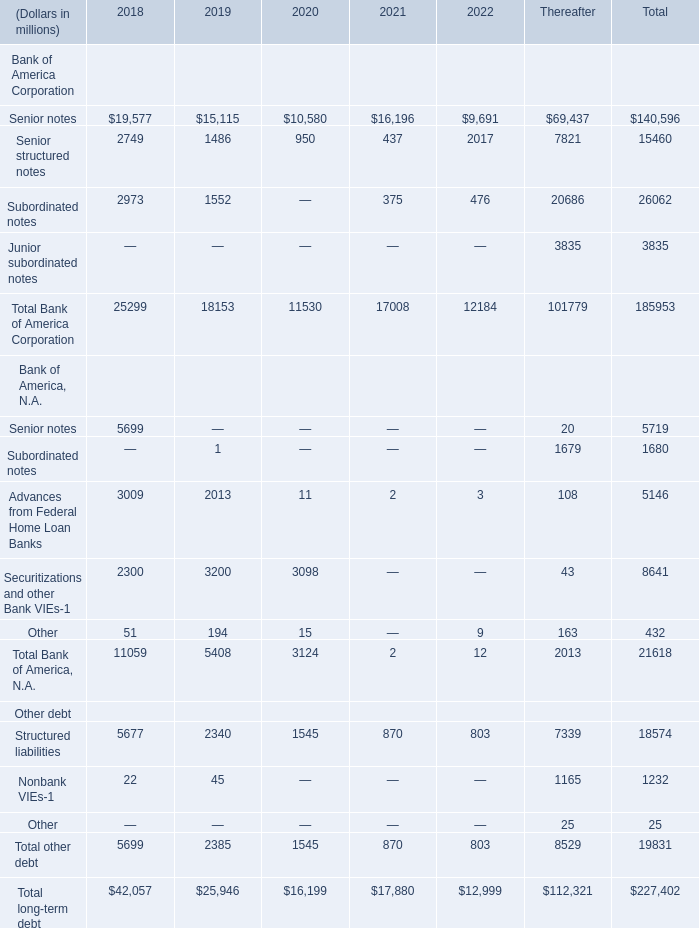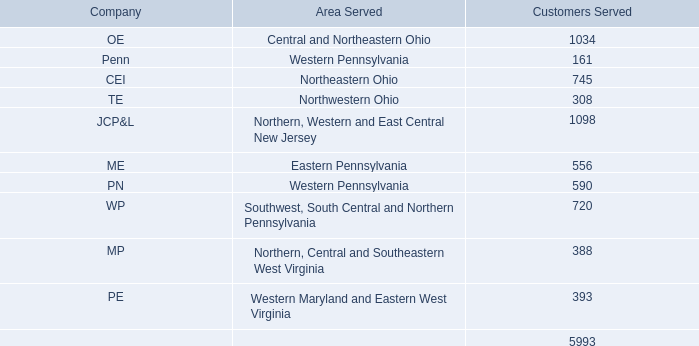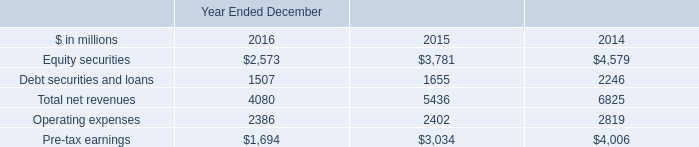What's the average of Senior structured notes in 2018,2019 and 2020 ? (in million) 
Computations: (((2749 + 1486) + 950) / 3)
Answer: 1728.33333. 